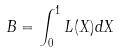<formula> <loc_0><loc_0><loc_500><loc_500>B = \int _ { 0 } ^ { 1 } L ( X ) d X</formula> 